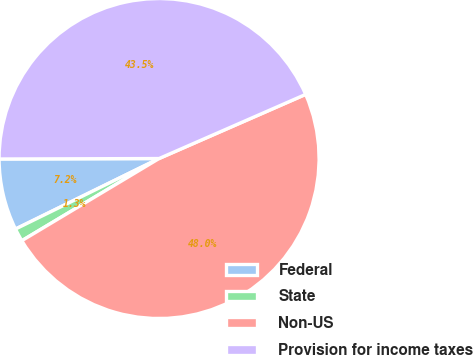Convert chart. <chart><loc_0><loc_0><loc_500><loc_500><pie_chart><fcel>Federal<fcel>State<fcel>Non-US<fcel>Provision for income taxes<nl><fcel>7.22%<fcel>1.32%<fcel>47.98%<fcel>43.48%<nl></chart> 